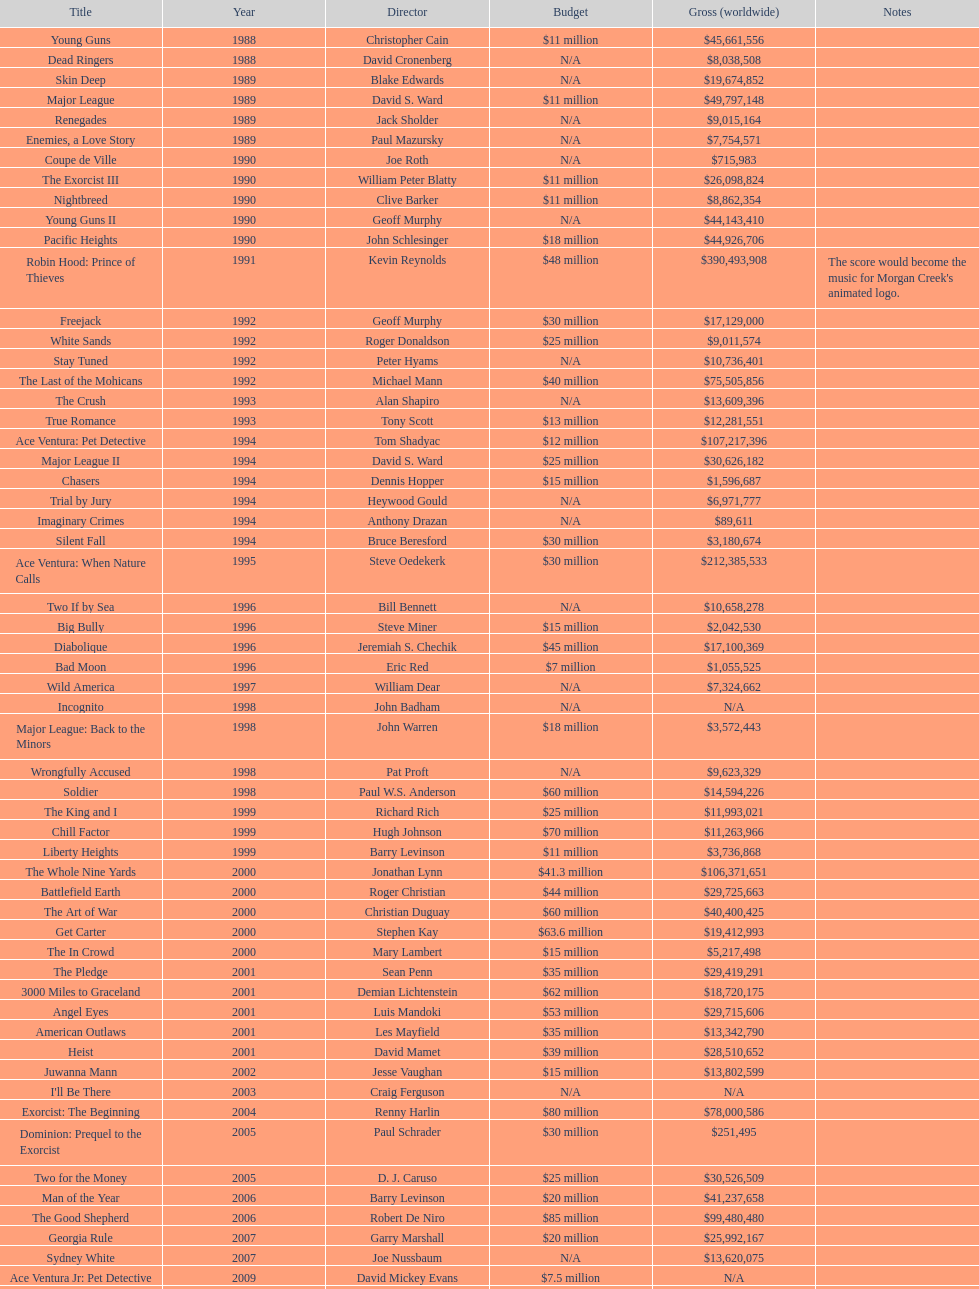Did the budget of young guns exceed or fall short of freejack's budget? Less. 